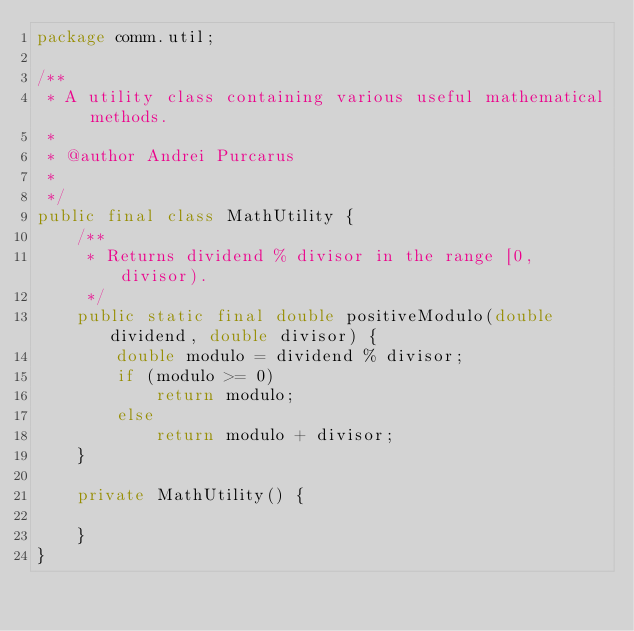<code> <loc_0><loc_0><loc_500><loc_500><_Java_>package comm.util;

/**
 * A utility class containing various useful mathematical methods.
 * 
 * @author Andrei Purcarus
 *
 */
public final class MathUtility {
	/**
	 * Returns dividend % divisor in the range [0, divisor).
	 */
	public static final double positiveModulo(double dividend, double divisor) {
		double modulo = dividend % divisor;
		if (modulo >= 0)
			return modulo;
		else
			return modulo + divisor;
	}

	private MathUtility() {

	}
}
</code> 